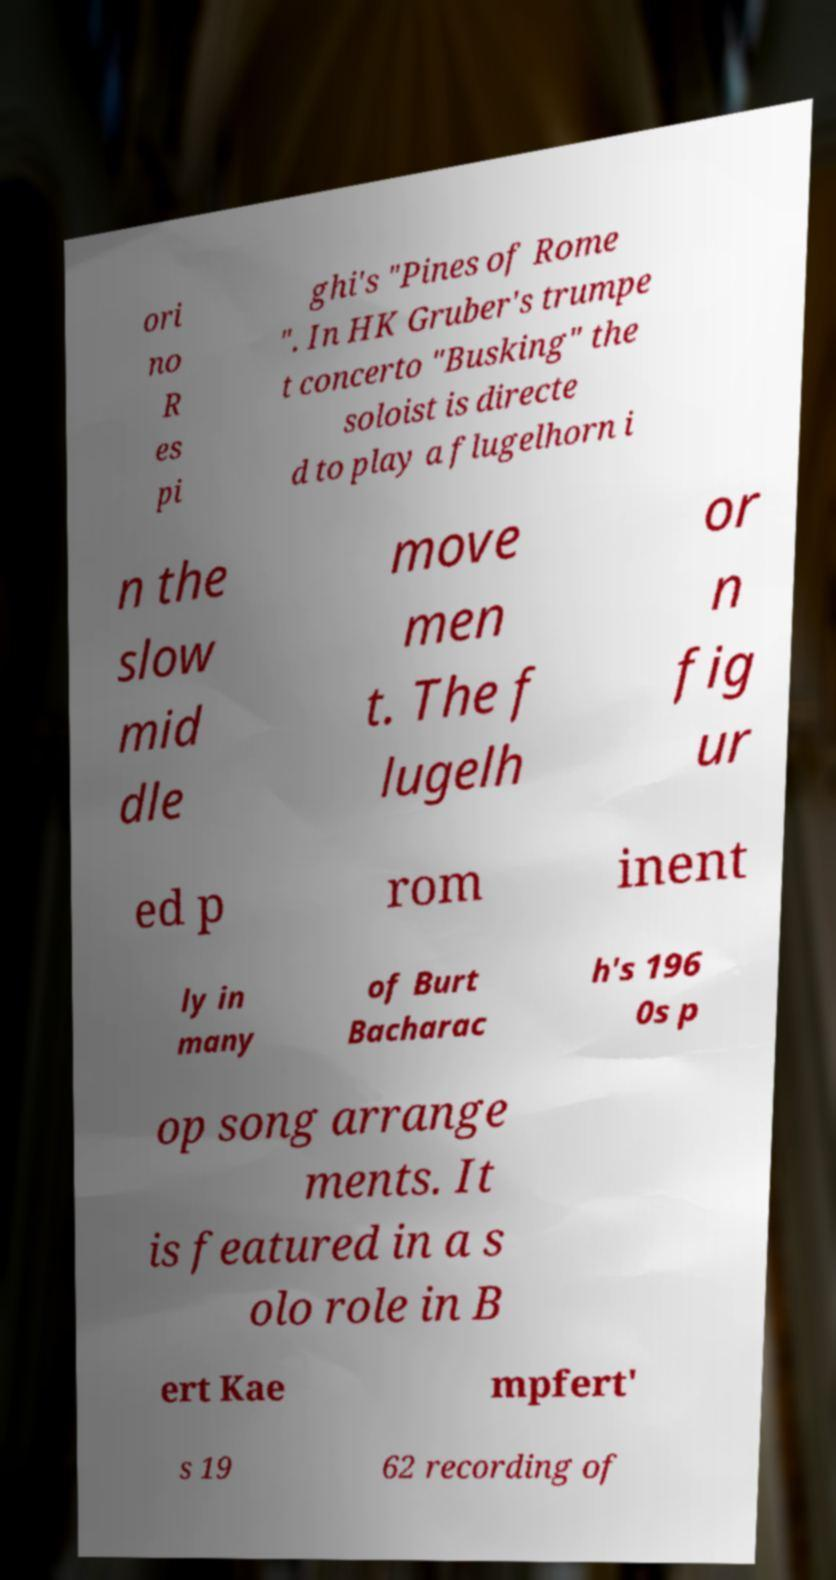Can you accurately transcribe the text from the provided image for me? ori no R es pi ghi's "Pines of Rome ". In HK Gruber's trumpe t concerto "Busking" the soloist is directe d to play a flugelhorn i n the slow mid dle move men t. The f lugelh or n fig ur ed p rom inent ly in many of Burt Bacharac h's 196 0s p op song arrange ments. It is featured in a s olo role in B ert Kae mpfert' s 19 62 recording of 